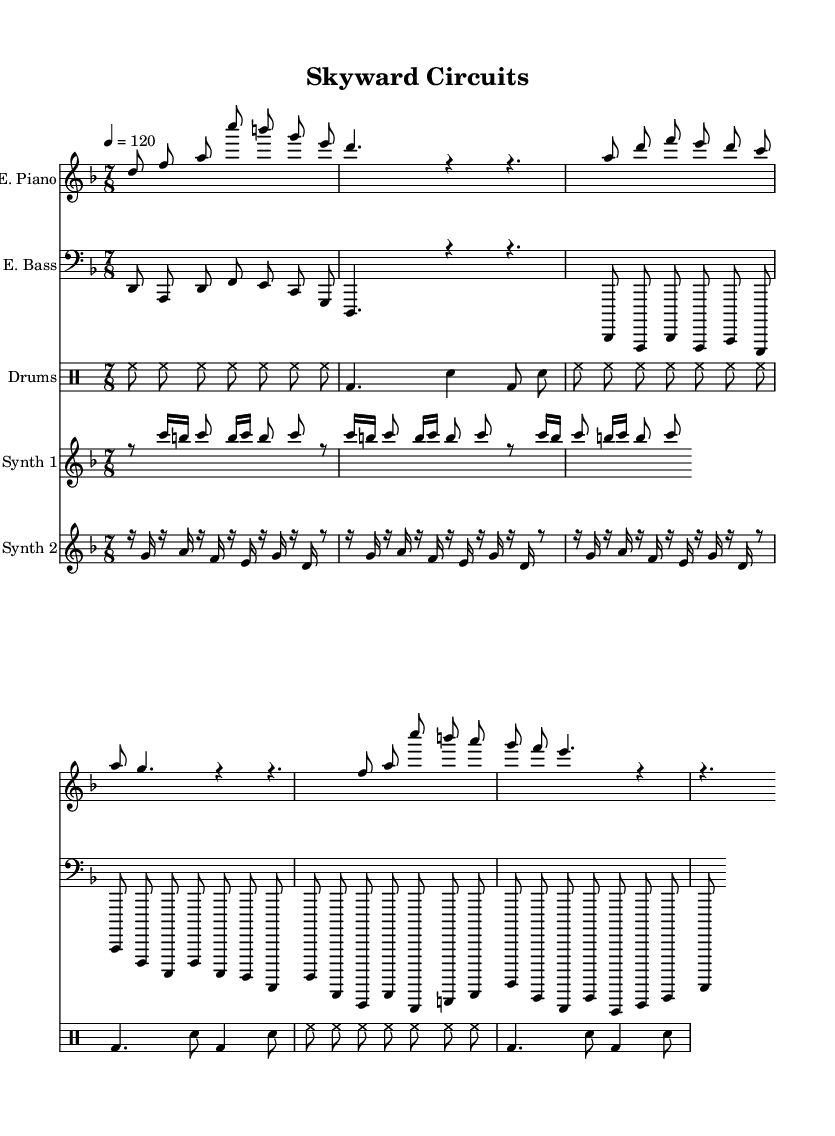What is the key signature of this music? The key signature indicated at the beginning of the score shows two flats, which corresponds to D minor.
Answer: D minor What is the time signature of this music? The time signature, shown in the beginning, is 7/8, meaning there are seven beats in each measure, and the eighth note gets the beat.
Answer: 7/8 What is the tempo marking for this piece? The tempo marking indicates a speed of 120 beats per minute, as noted in the score.
Answer: 120 How many measures are there in the electric piano part's intro? Counting the measures in the electric piano part's intro reveals there are two measures as depicted by the music notation before moving on to the verse.
Answer: 2 What type of drum beat is predominantly used throughout the piece? The drum part primarily utilizes a hi-hat pattern throughout, indicated by the consistent hi-hat notes and supported by bass drum and snare accents.
Answer: Hi-hat In which section does the synth glitch first appear? The synth glitch part first appears after the electric piano's intro section, indicated by its distinct rhythmic pattern and presence of rests.
Answer: After the intro How many notes are in the synth propeller phrase? By counting the notes displayed in the synth propeller section, there are a total of 12 notes in the phrase as shown in its repetitive structure.
Answer: 12 